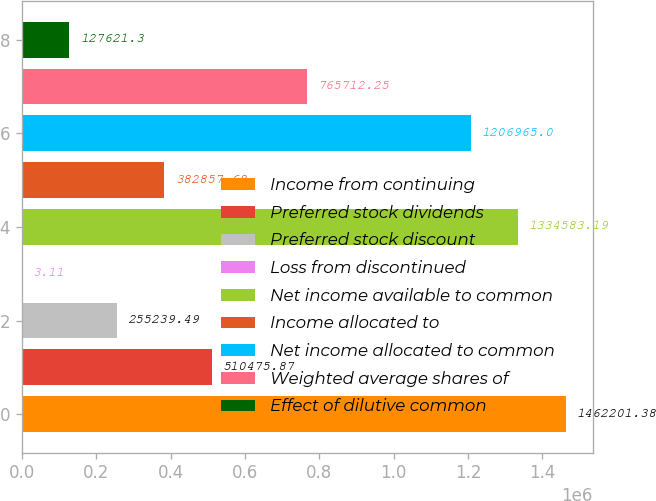Convert chart to OTSL. <chart><loc_0><loc_0><loc_500><loc_500><bar_chart><fcel>Income from continuing<fcel>Preferred stock dividends<fcel>Preferred stock discount<fcel>Loss from discontinued<fcel>Net income available to common<fcel>Income allocated to<fcel>Net income allocated to common<fcel>Weighted average shares of<fcel>Effect of dilutive common<nl><fcel>1.4622e+06<fcel>510476<fcel>255239<fcel>3.11<fcel>1.33458e+06<fcel>382858<fcel>1.20696e+06<fcel>765712<fcel>127621<nl></chart> 